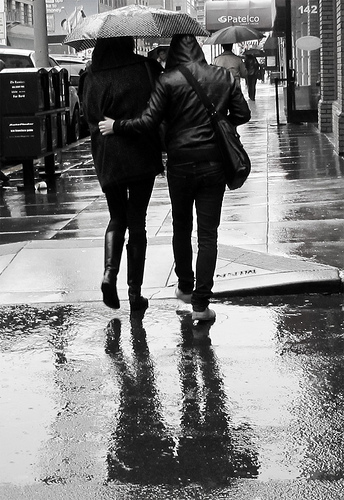Please transcribe the text information in this image. 142 Patelco 